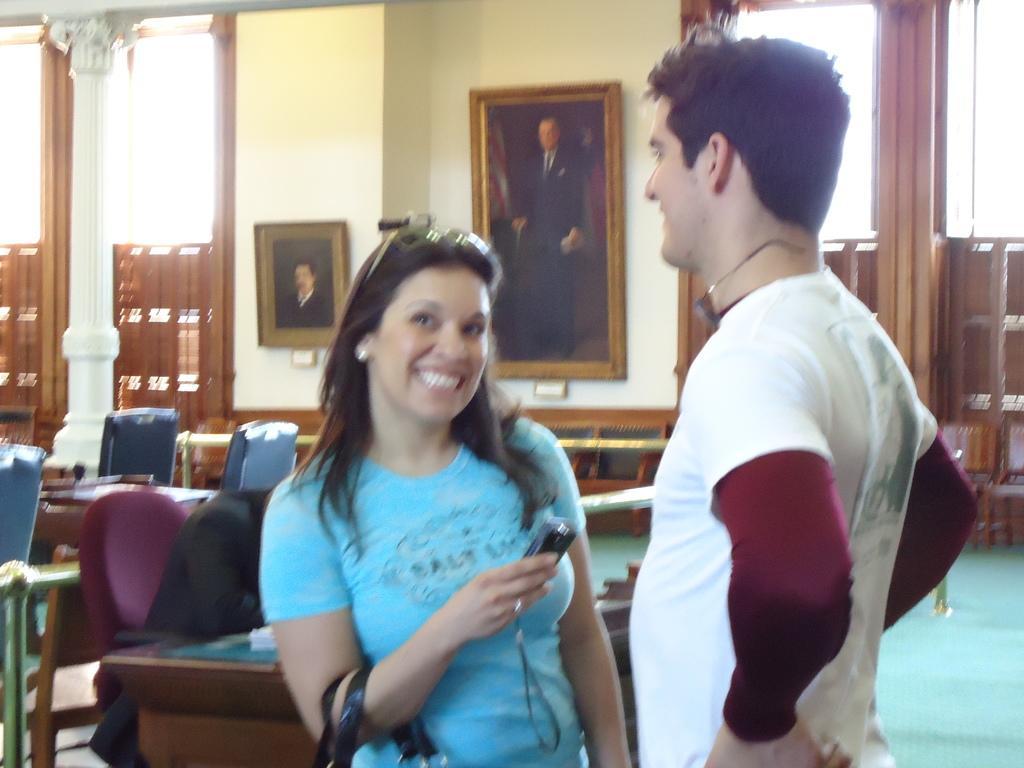Describe this image in one or two sentences. In this image I can see a woman wearing blue t-shirt, smiling and holding mobile and bag in her hand. Beside her there is a man wearing white t-shirt, standing and smiling. In the background I can see a wall and some frames to it. On the left side of the picture I can see a pillar. And in the background there are some chairs and table and some papers on it. 